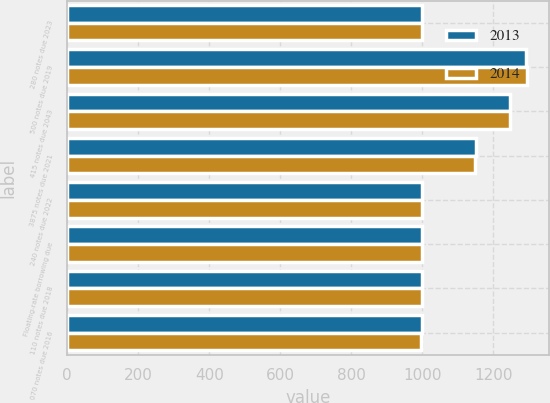Convert chart. <chart><loc_0><loc_0><loc_500><loc_500><stacked_bar_chart><ecel><fcel>280 notes due 2023<fcel>500 notes due 2019<fcel>415 notes due 2043<fcel>3875 notes due 2021<fcel>240 notes due 2022<fcel>Floating-rate borrowing due<fcel>110 notes due 2018<fcel>070 notes due 2016<nl><fcel>2013<fcel>1000<fcel>1291<fcel>1246<fcel>1150<fcel>1000<fcel>1000<fcel>999<fcel>998<nl><fcel>2014<fcel>1000<fcel>1293<fcel>1246<fcel>1148<fcel>1000<fcel>1000<fcel>998<fcel>997<nl></chart> 